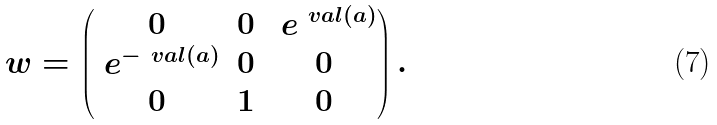<formula> <loc_0><loc_0><loc_500><loc_500>\ w = \begin{pmatrix} 0 & 0 & \ e ^ { \ v a l ( a ) } \\ \ e ^ { - \ v a l ( a ) } & 0 & 0 \\ 0 & 1 & 0 \end{pmatrix} .</formula> 